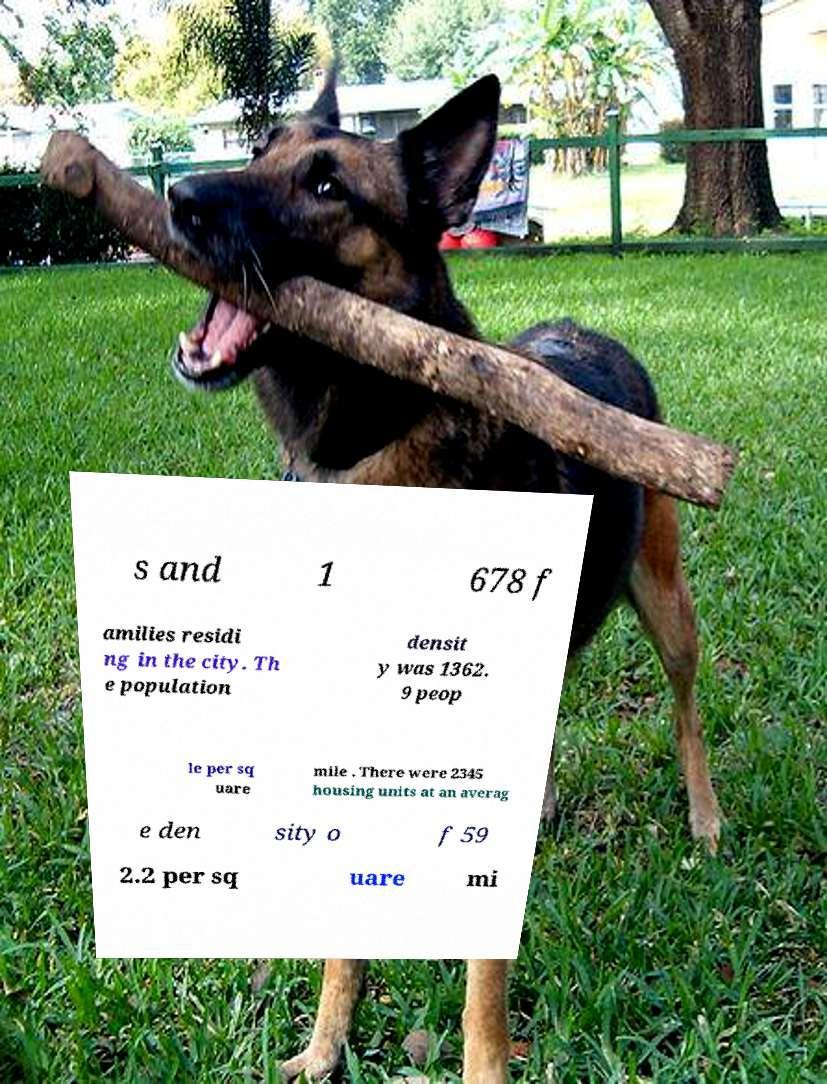I need the written content from this picture converted into text. Can you do that? s and 1 678 f amilies residi ng in the city. Th e population densit y was 1362. 9 peop le per sq uare mile . There were 2345 housing units at an averag e den sity o f 59 2.2 per sq uare mi 